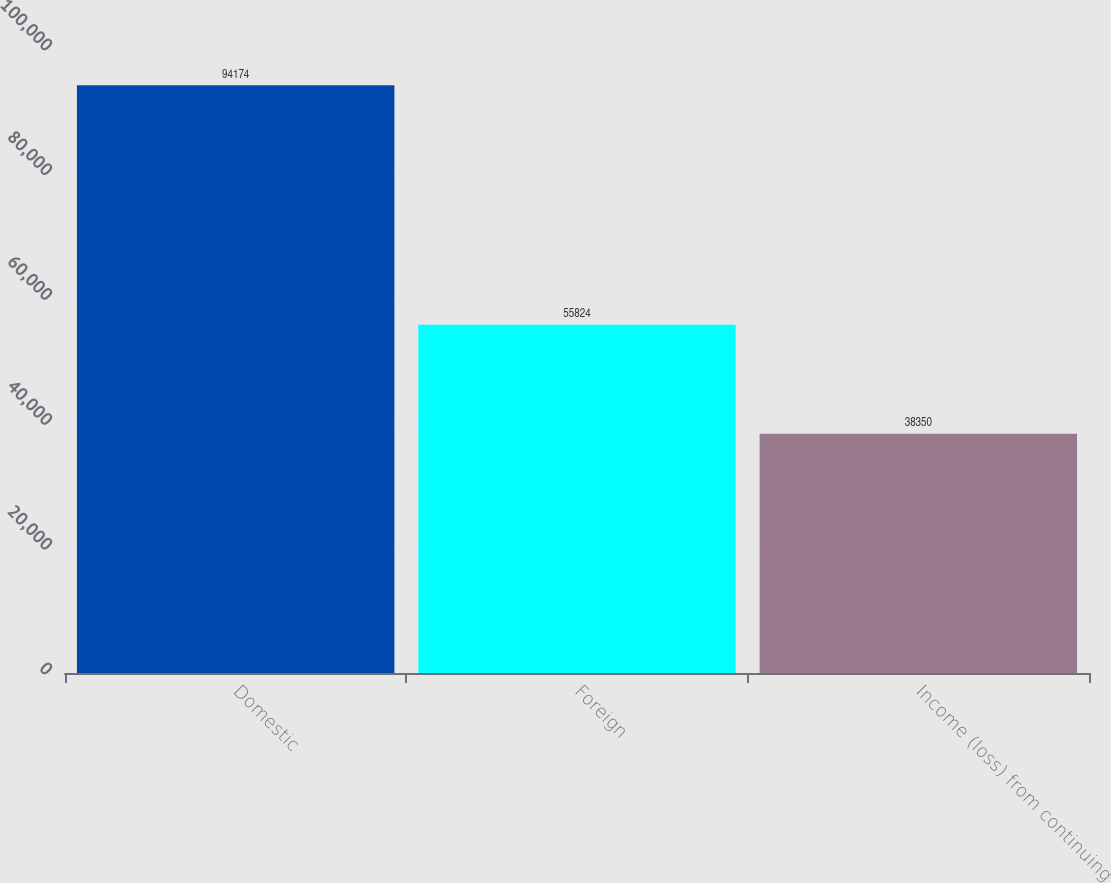<chart> <loc_0><loc_0><loc_500><loc_500><bar_chart><fcel>Domestic<fcel>Foreign<fcel>Income (loss) from continuing<nl><fcel>94174<fcel>55824<fcel>38350<nl></chart> 